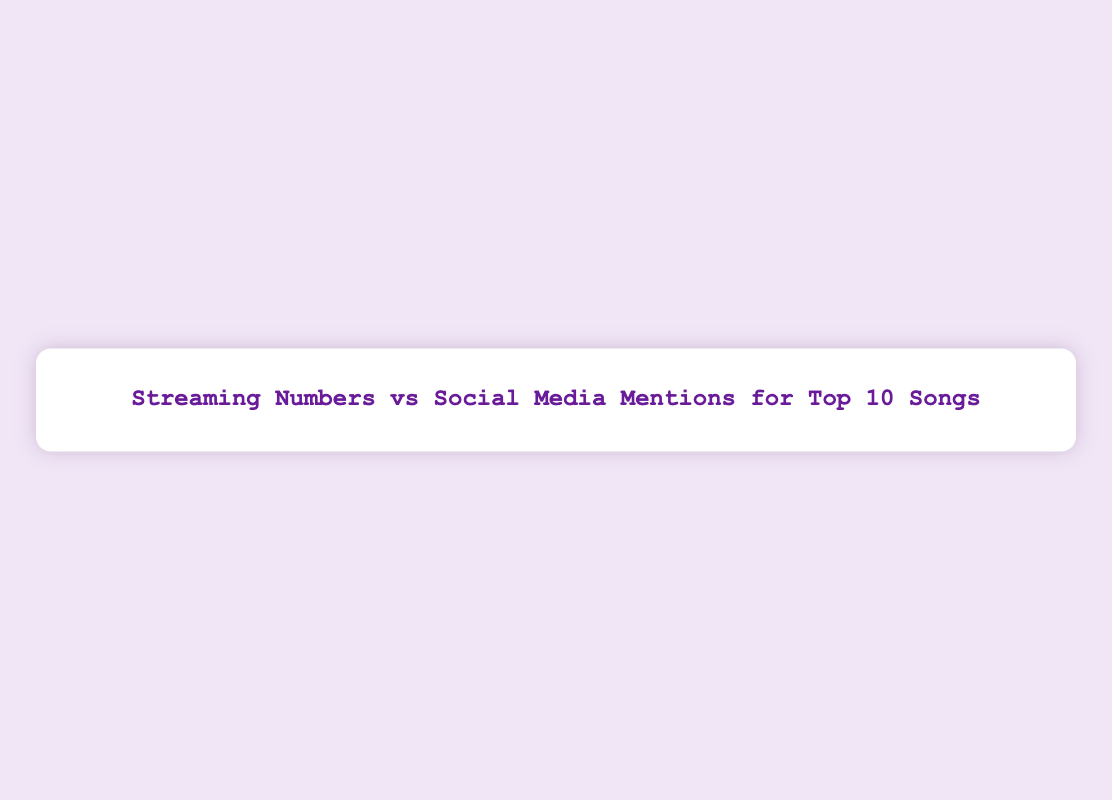What is the title of the scatter plot? The title of the scatter plot is written at the top and reads "Streaming Numbers vs Social Media Mentions for Top 10 Songs".
Answer: Streaming Numbers vs Social Media Mentions for Top 10 Songs How many data points are present in the scatter plot? Each song represents one data point, and there are 10 songs listed in the data.
Answer: 10 Which song has the highest streaming numbers? The data points for streaming numbers are plotted along the x-axis. "Blinding Lights" by The Weeknd is at the far right, indicating it has the highest streaming numbers.
Answer: Blinding Lights What is the range of social media mentions represented on the y-axis? The y-axis range is given from 1100 to 1800 social media mentions.
Answer: 1100 to 1800 Which song has the lowest popularity index, and what size is the marker representing it? "Everything I Wanted" by Billie Eilish has the lowest popularity index (85). The marker size is the popularity index divided by 2, so 85/2 = 42.5.
Answer: Everything I Wanted, 42.5 Compare the streaming numbers of "Good 4 U" and "Savage Love". Which one has higher streaming numbers and by how much? "Good 4 U" by Olivia Rodrigo has streaming numbers of 2400. "Savage Love" by Jawsh 685 & Jason Derulo has 1800 streaming numbers. The difference is 2400 - 1800 = 600.
Answer: Good 4 U, 600 Which song has the most social media mentions? The song with the highest point on the y-axis represents the most social media mentions, and "Watermelon Sugar" by Harry Styles has 1700 social media mentions.
Answer: Watermelon Sugar Is there a song with both higher streaming numbers and higher social media mentions than "Circles"? "Circles" by Post Malone has streaming numbers of 2300 and social media mentions of 1350. "Blinding Lights" by The Weeknd and "Good 4 U" by Olivia Rodrigo have both higher streaming numbers and higher social media mentions.
Answer: Yes Identify the song with a popularity index of 88 and describe its position in the scatter plot. "Say So" by Doja Cat has a popularity index of 88. It is positioned at 1900 on the x-axis (streaming numbers) and 1450 on the y-axis (social media mentions).
Answer: Say So What is the color scheme used for the markers, and what does it represent? The color scheme of the markers is represented by the colorscale 'Viridis', which indicates different levels of popularity index.
Answer: Viridis, popularity index 